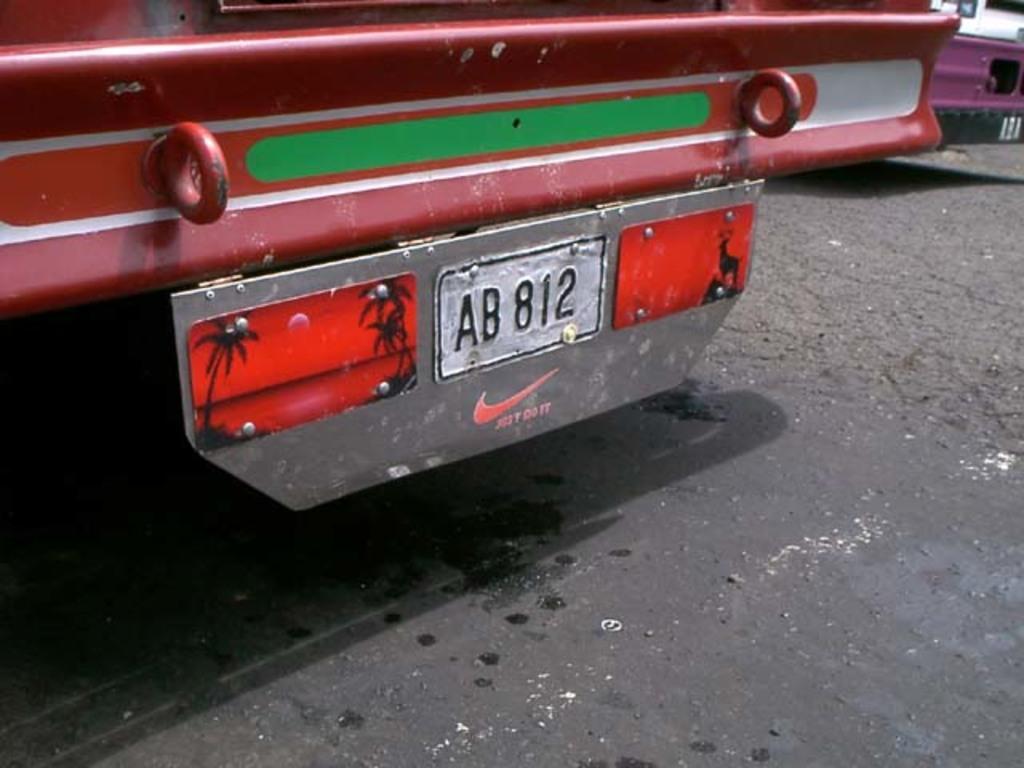Could you give a brief overview of what you see in this image? In this image I can see the ground and a vehicle which is red, white and green in color on the ground. I can see the number plate of the vehicle. In the background I can see another vehicle. 